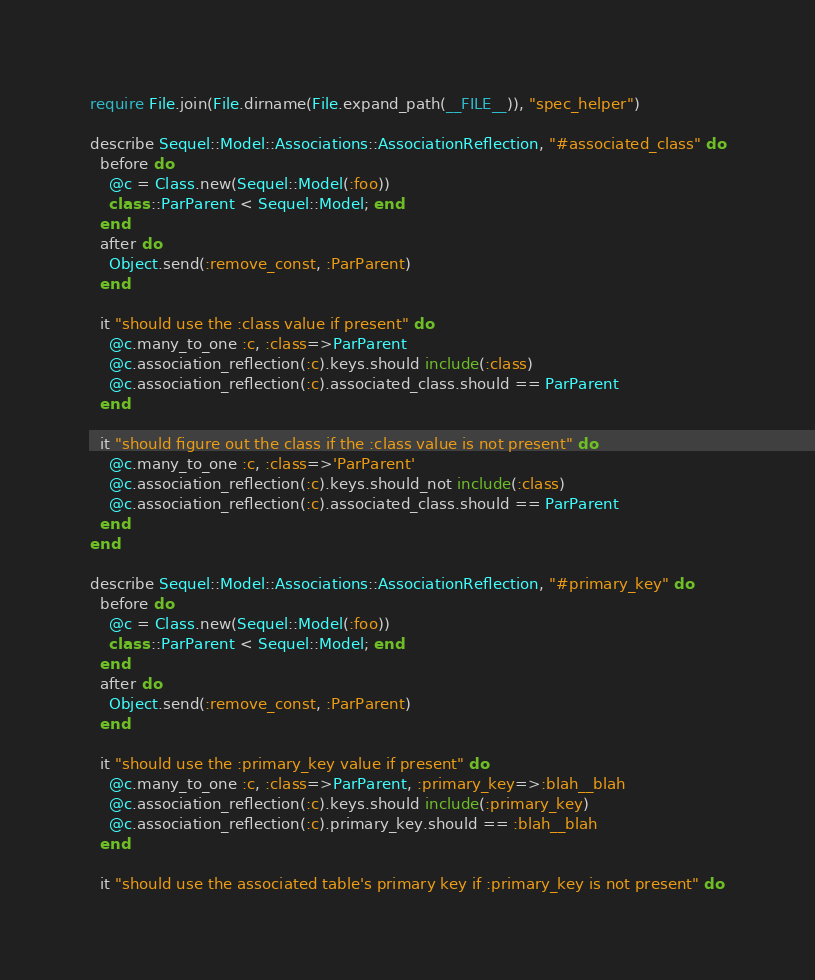Convert code to text. <code><loc_0><loc_0><loc_500><loc_500><_Ruby_>require File.join(File.dirname(File.expand_path(__FILE__)), "spec_helper")

describe Sequel::Model::Associations::AssociationReflection, "#associated_class" do
  before do
    @c = Class.new(Sequel::Model(:foo))
    class ::ParParent < Sequel::Model; end
  end
  after do
    Object.send(:remove_const, :ParParent)
  end

  it "should use the :class value if present" do
    @c.many_to_one :c, :class=>ParParent
    @c.association_reflection(:c).keys.should include(:class)
    @c.association_reflection(:c).associated_class.should == ParParent
  end

  it "should figure out the class if the :class value is not present" do
    @c.many_to_one :c, :class=>'ParParent'
    @c.association_reflection(:c).keys.should_not include(:class)
    @c.association_reflection(:c).associated_class.should == ParParent
  end
end

describe Sequel::Model::Associations::AssociationReflection, "#primary_key" do
  before do
    @c = Class.new(Sequel::Model(:foo))
    class ::ParParent < Sequel::Model; end
  end
  after do
    Object.send(:remove_const, :ParParent)
  end

  it "should use the :primary_key value if present" do
    @c.many_to_one :c, :class=>ParParent, :primary_key=>:blah__blah
    @c.association_reflection(:c).keys.should include(:primary_key)
    @c.association_reflection(:c).primary_key.should == :blah__blah
  end

  it "should use the associated table's primary key if :primary_key is not present" do</code> 